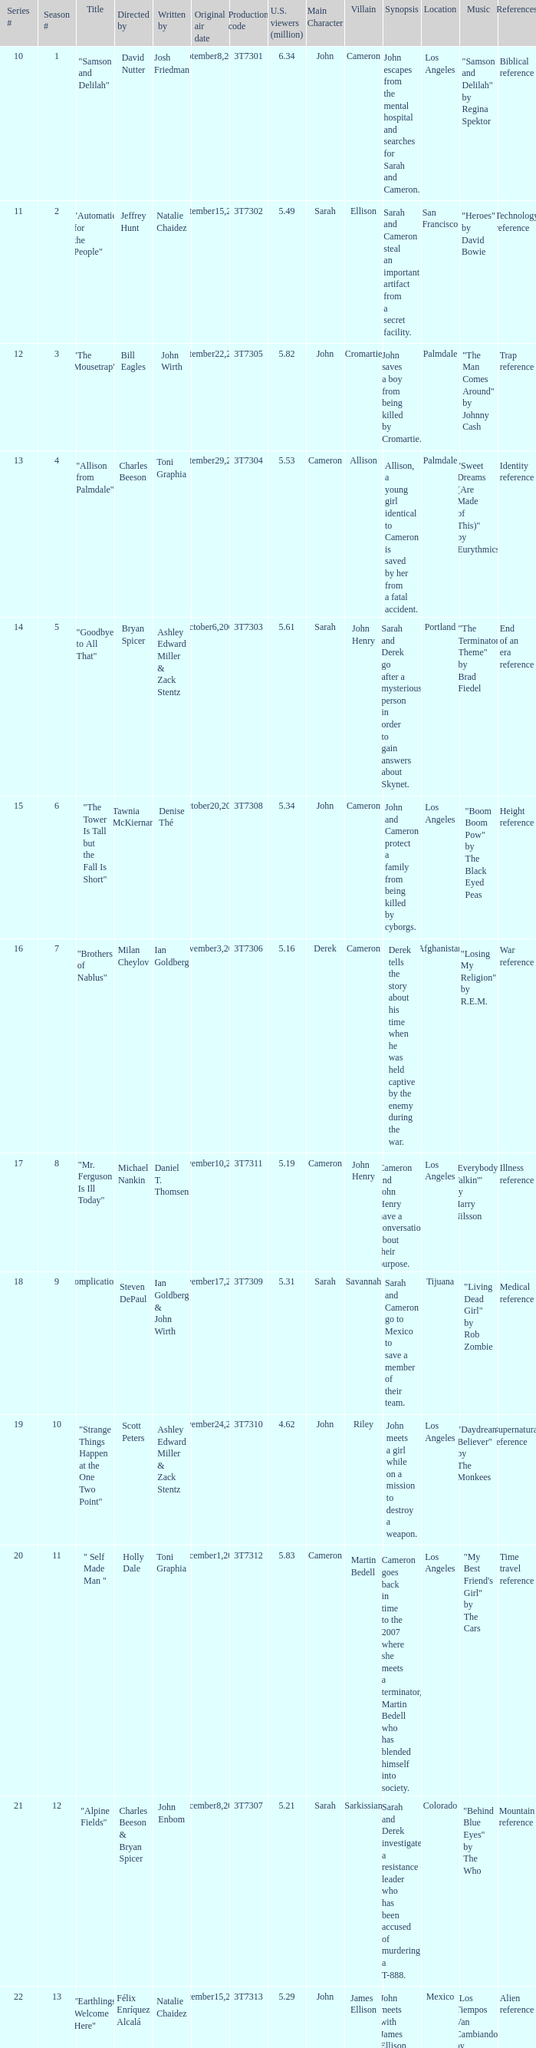Which episode number was directed by Bill Eagles? 12.0. 